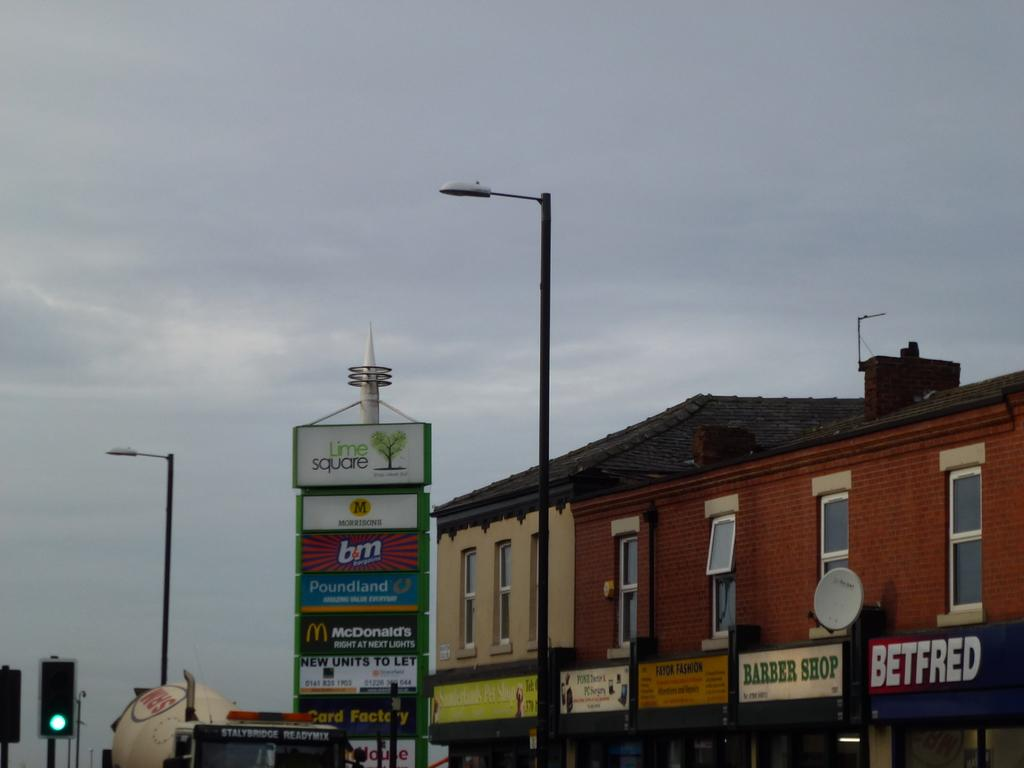<image>
Relay a brief, clear account of the picture shown. Several businesses, including Betfred, are advertised on a city street. 